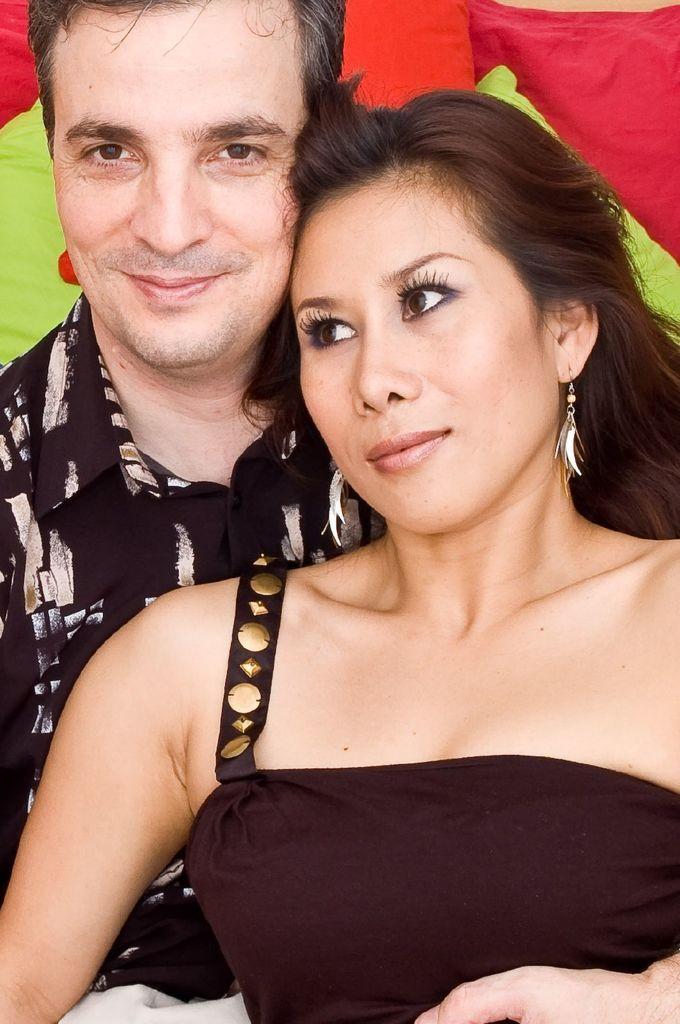In one or two sentences, can you explain what this image depicts? In this picture we can see two persons. Behind two persons, there are some colorful objects. 